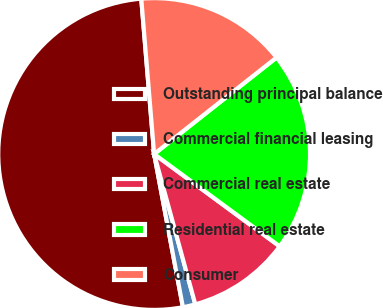Convert chart. <chart><loc_0><loc_0><loc_500><loc_500><pie_chart><fcel>Outstanding principal balance<fcel>Commercial financial leasing<fcel>Commercial real estate<fcel>Residential real estate<fcel>Consumer<nl><fcel>51.64%<fcel>1.3%<fcel>10.65%<fcel>20.72%<fcel>15.69%<nl></chart> 